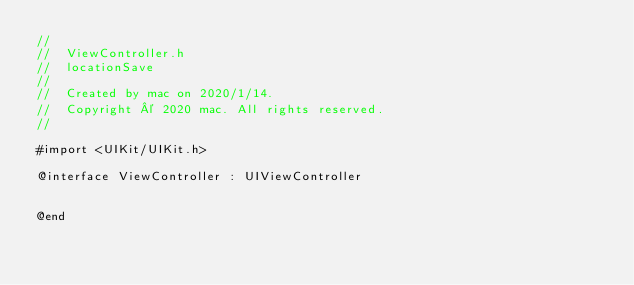Convert code to text. <code><loc_0><loc_0><loc_500><loc_500><_C_>//
//  ViewController.h
//  locationSave
//
//  Created by mac on 2020/1/14.
//  Copyright © 2020 mac. All rights reserved.
//

#import <UIKit/UIKit.h>

@interface ViewController : UIViewController


@end

</code> 